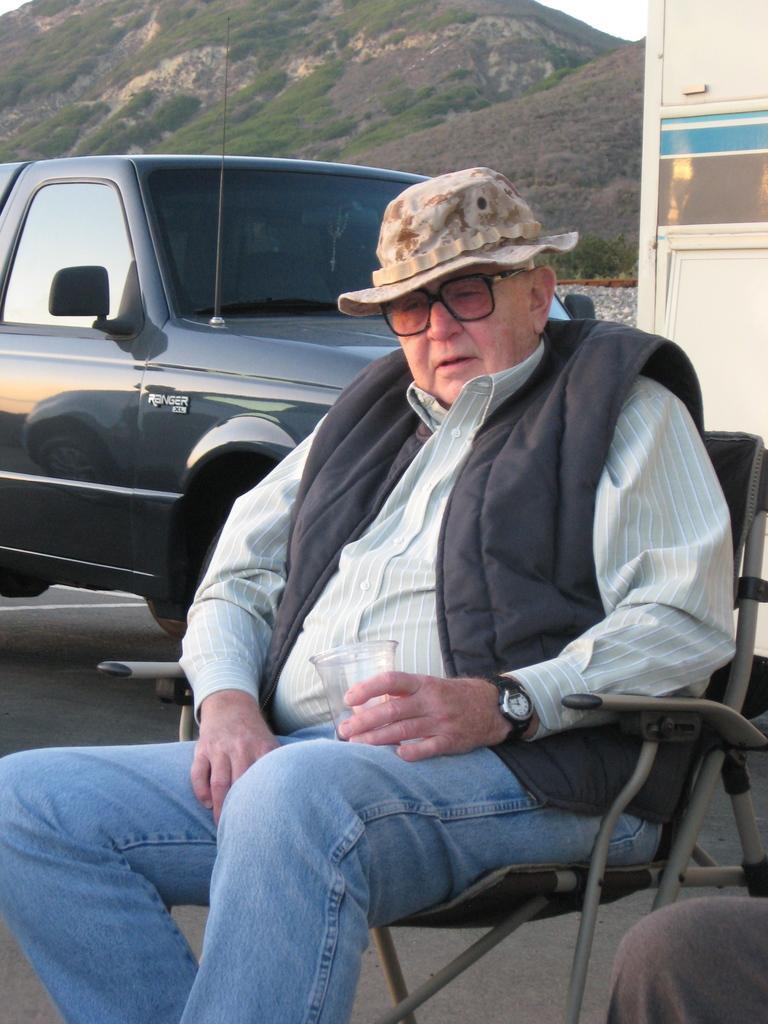Could you give a brief overview of what you see in this image? In the picture there is a man sitting on a chair and behind him there is a car, there is some other person beside the man and in the background there are mountains. 